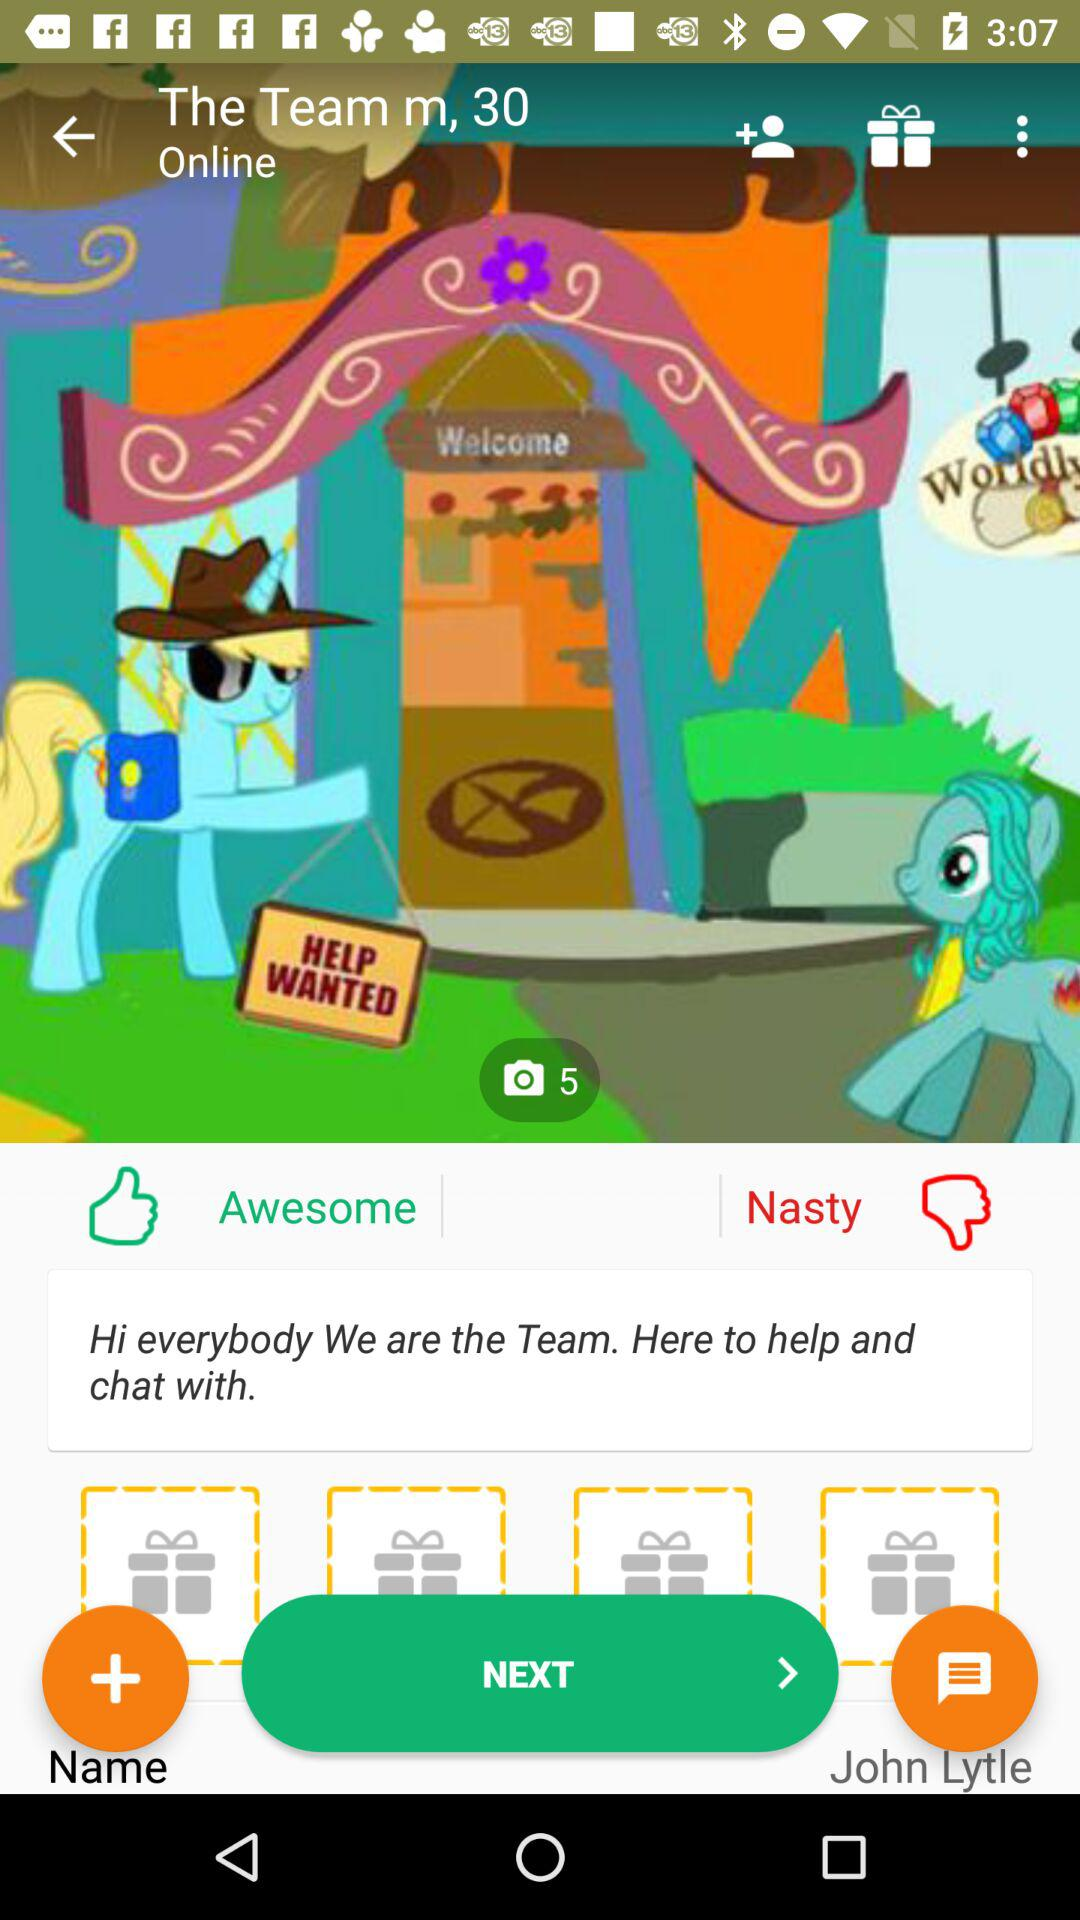What is the name of the person? The name of the person is John Lytle. 